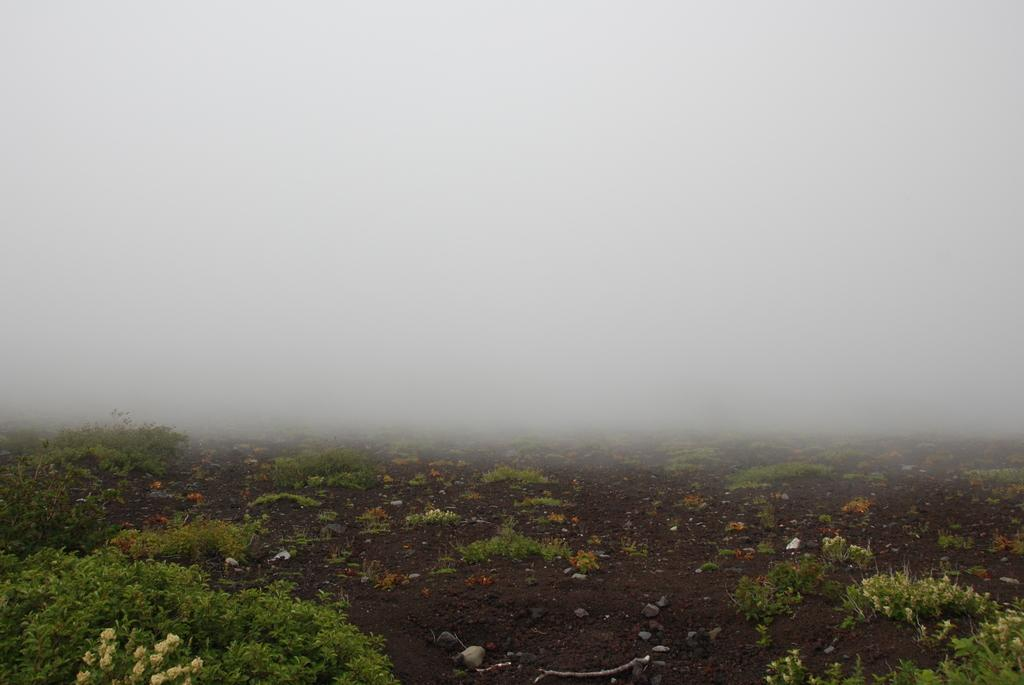Where was the image taken? The image was clicked outside the city. What can be seen in the foreground of the image? There are plants and stones on the ground in the foreground of the image. What is visible in the background of the image? The sky is visible in the background of the image. What type of vest is the robin wearing in the image? There is no robin or vest present in the image. What type of coach can be seen in the background of the image? There is no coach present in the image; only plants, stones, and the sky are visible. 